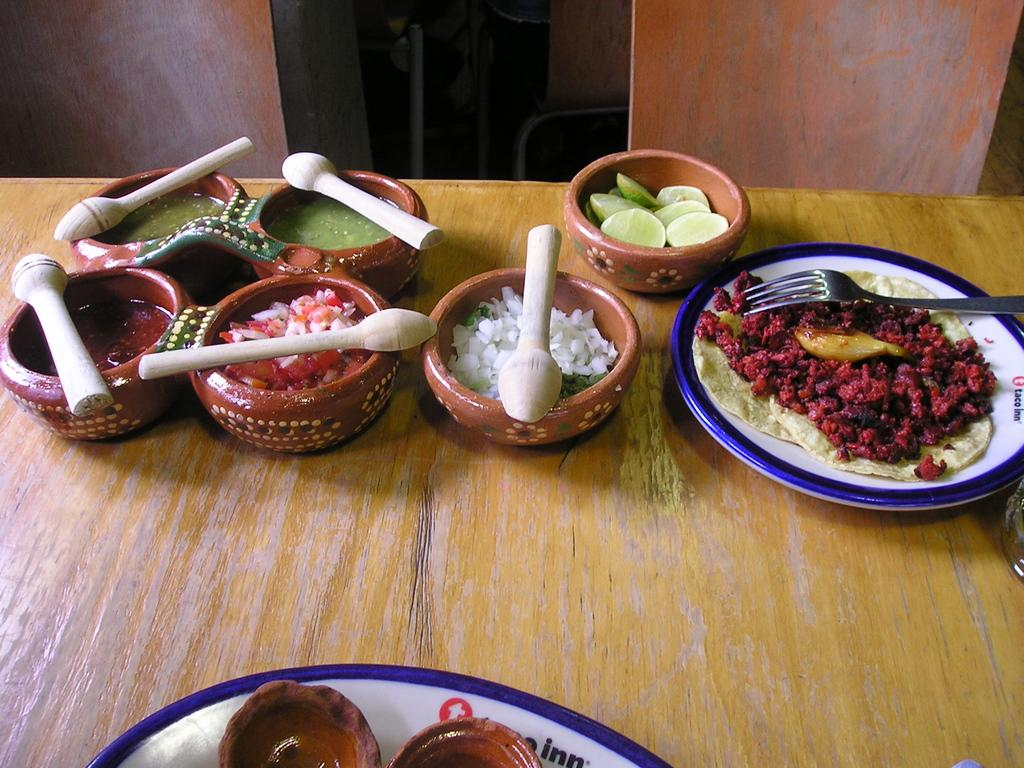What is the main subject in the center of the image? There is food in the center of the image. What utensils are present in the image? Spoons and forks are visible in the image. How are the food, spoons, and forks arranged in the image? They are placed in bowls. Where are the bowls located in the image? The bowls are placed on a table. What grade of gun is visible in the image? There is no gun present in the image; it features food, spoons, forks, and bowls. 